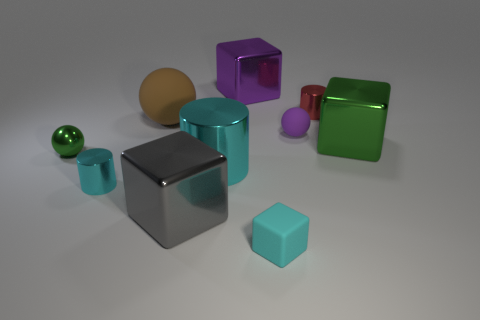Subtract all big blocks. How many blocks are left? 1 Subtract all yellow balls. How many cyan cylinders are left? 2 Subtract all cyan blocks. How many blocks are left? 3 Subtract all blocks. How many objects are left? 6 Add 8 big rubber spheres. How many big rubber spheres are left? 9 Add 4 big green rubber balls. How many big green rubber balls exist? 4 Subtract 0 blue spheres. How many objects are left? 10 Subtract all cyan cylinders. Subtract all purple cubes. How many cylinders are left? 1 Subtract all big green cubes. Subtract all tiny cyan cylinders. How many objects are left? 8 